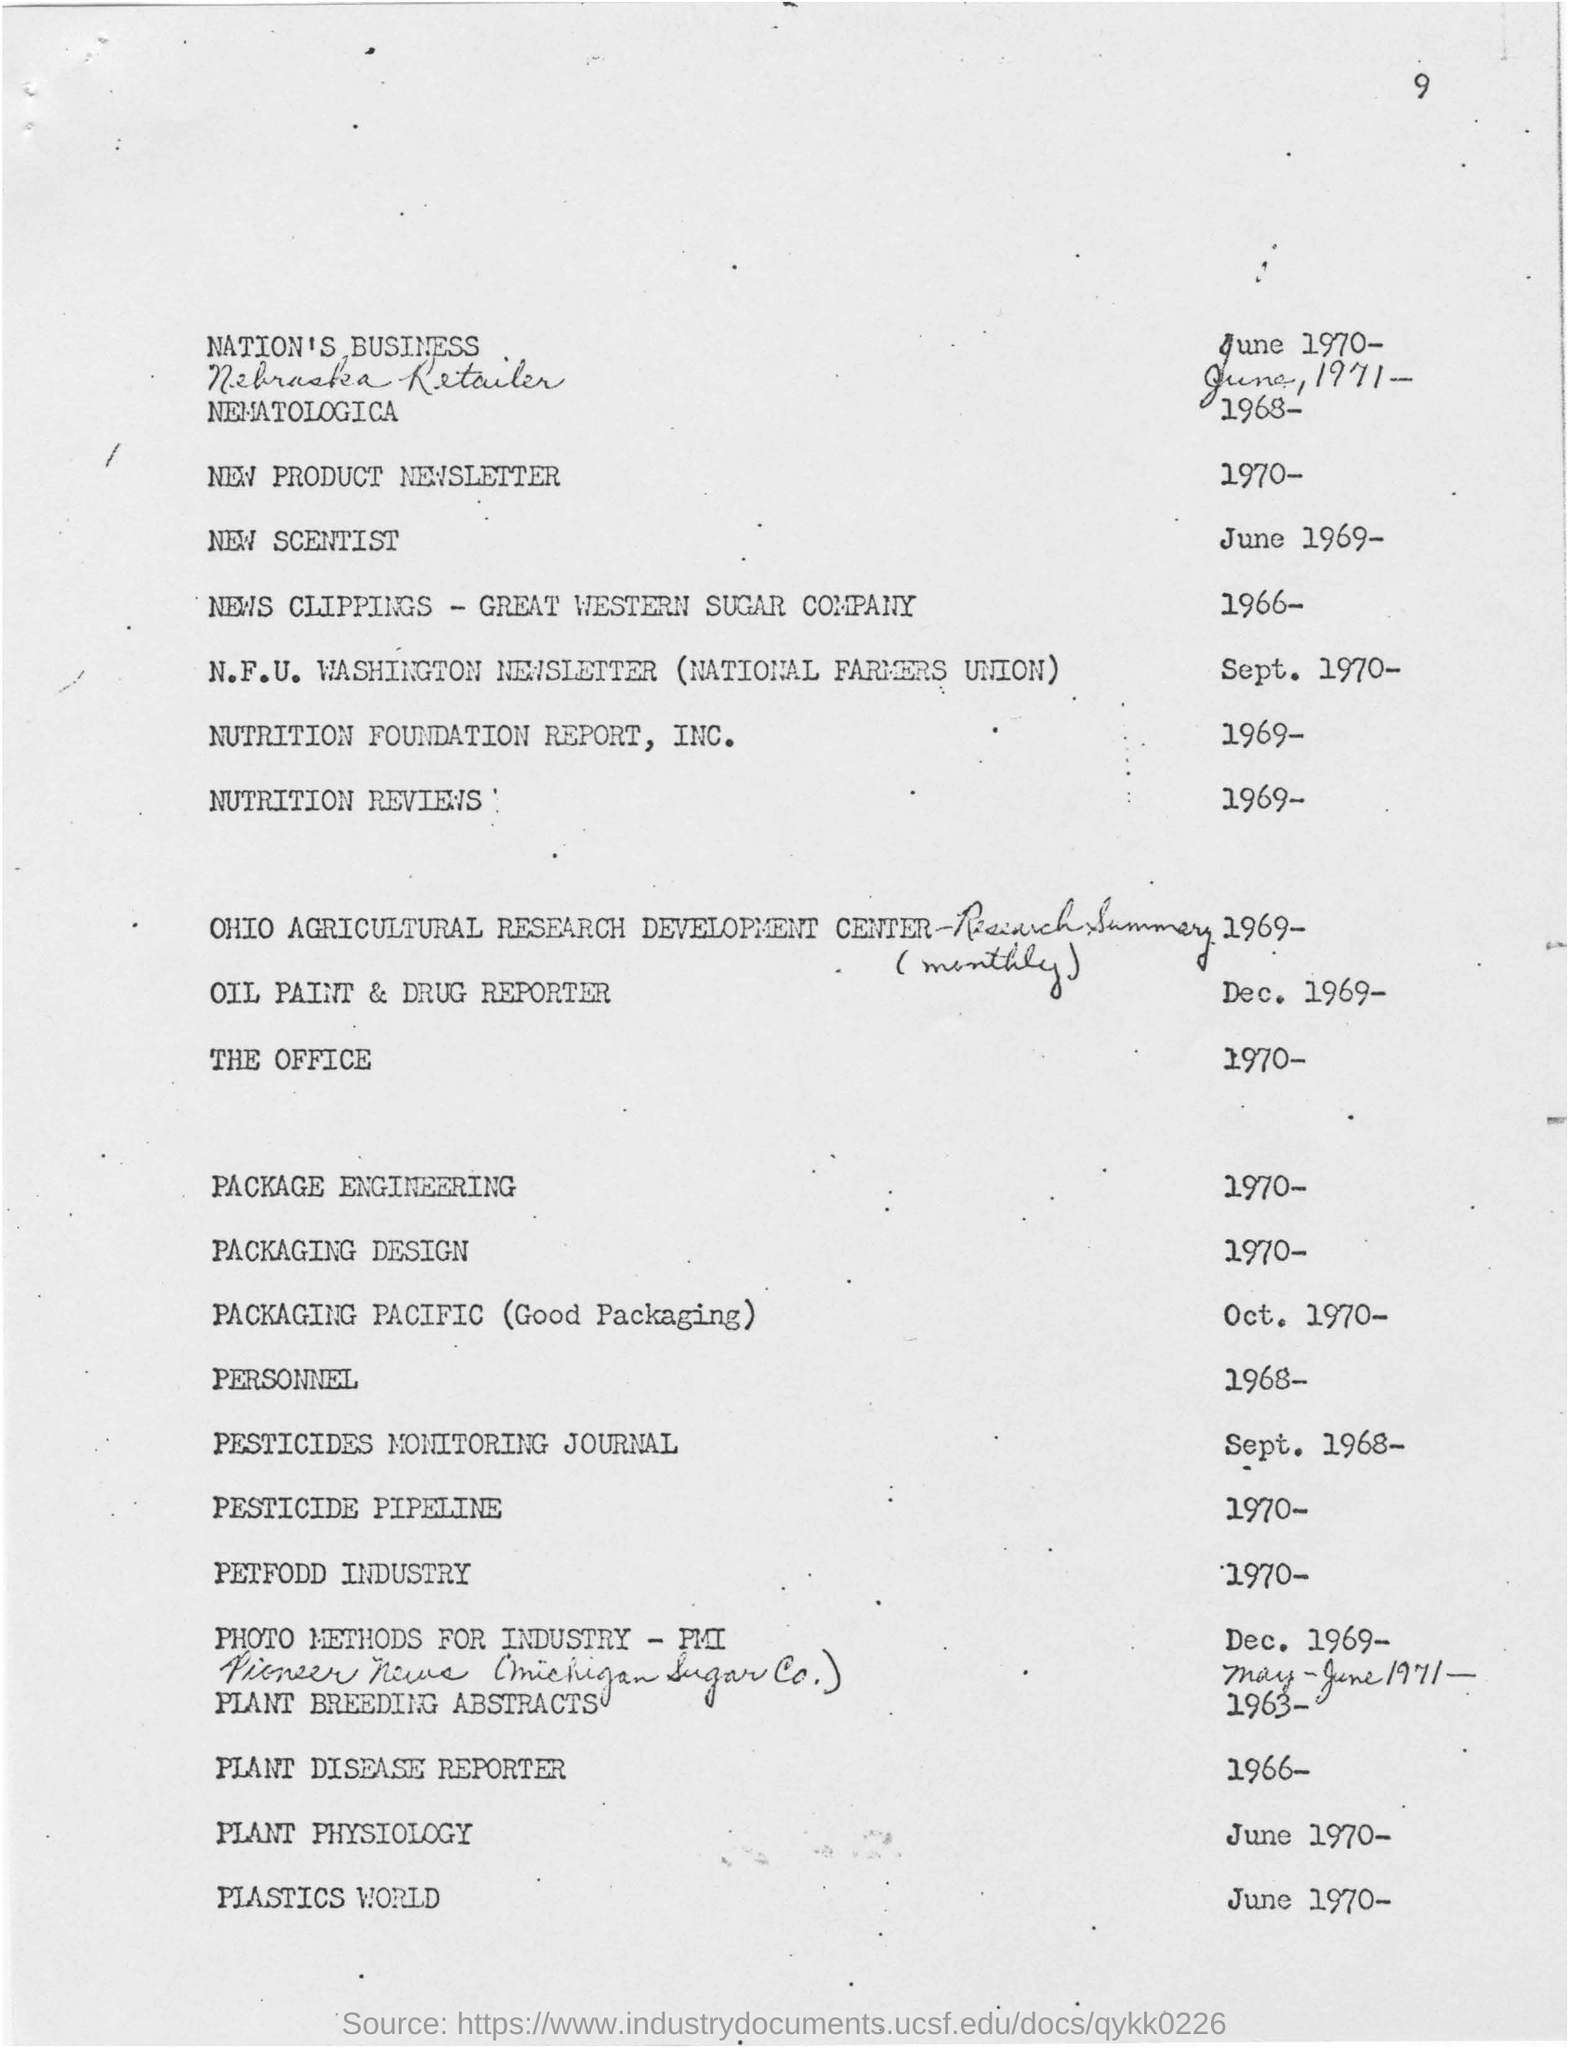When is the New Scientist dated?
Make the answer very short. JUne 1969. When is the Plastics World dated?
Offer a terse response. June 1970. What is the page number?
Provide a succinct answer. 9. 